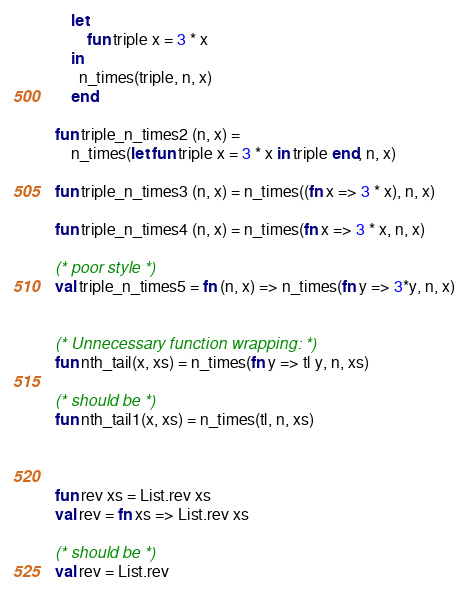<code> <loc_0><loc_0><loc_500><loc_500><_SML_>    let
        fun triple x = 3 * x
    in
      n_times(triple, n, x)
    end

fun triple_n_times2 (n, x) =
    n_times(let fun triple x = 3 * x in triple end, n, x)

fun triple_n_times3 (n, x) = n_times((fn x => 3 * x), n, x)

fun triple_n_times4 (n, x) = n_times(fn x => 3 * x, n, x)

(* poor style *)
val triple_n_times5 = fn (n, x) => n_times(fn y => 3*y, n, x)


(* Unnecessary function wrapping: *)
fun nth_tail(x, xs) = n_times(fn y => tl y, n, xs)

(* should be *)
fun nth_tail1(x, xs) = n_times(tl, n, xs)



fun rev xs = List.rev xs
val rev = fn xs => List.rev xs

(* should be *)
val rev = List.rev</code> 